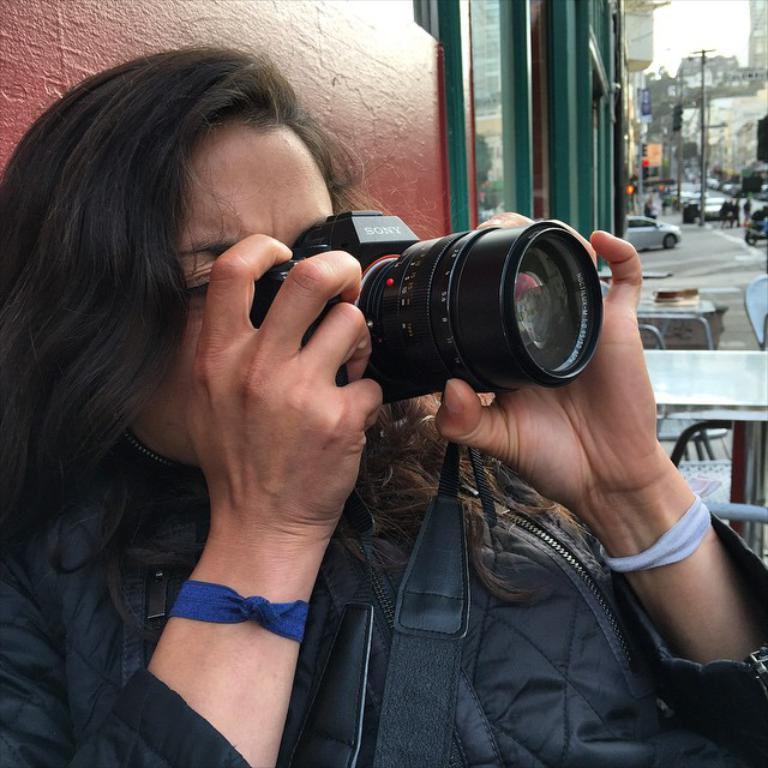Who is the main subject in the image? There is a woman in the image. What is the woman doing in the image? The woman is taking a photograph. Where is the woman sitting in the image? The woman is sitting on a chair. What can be seen in the background of the image? There is a road, a vehicle moving on the road, a pole, a traffic signal, and buildings in the background of the image. How many cacti can be seen growing on the land in the image? There are no cacti or land visible in the image. What type of brick is used to construct the buildings in the image? The image does not provide information about the type of brick used to construct the buildings. 